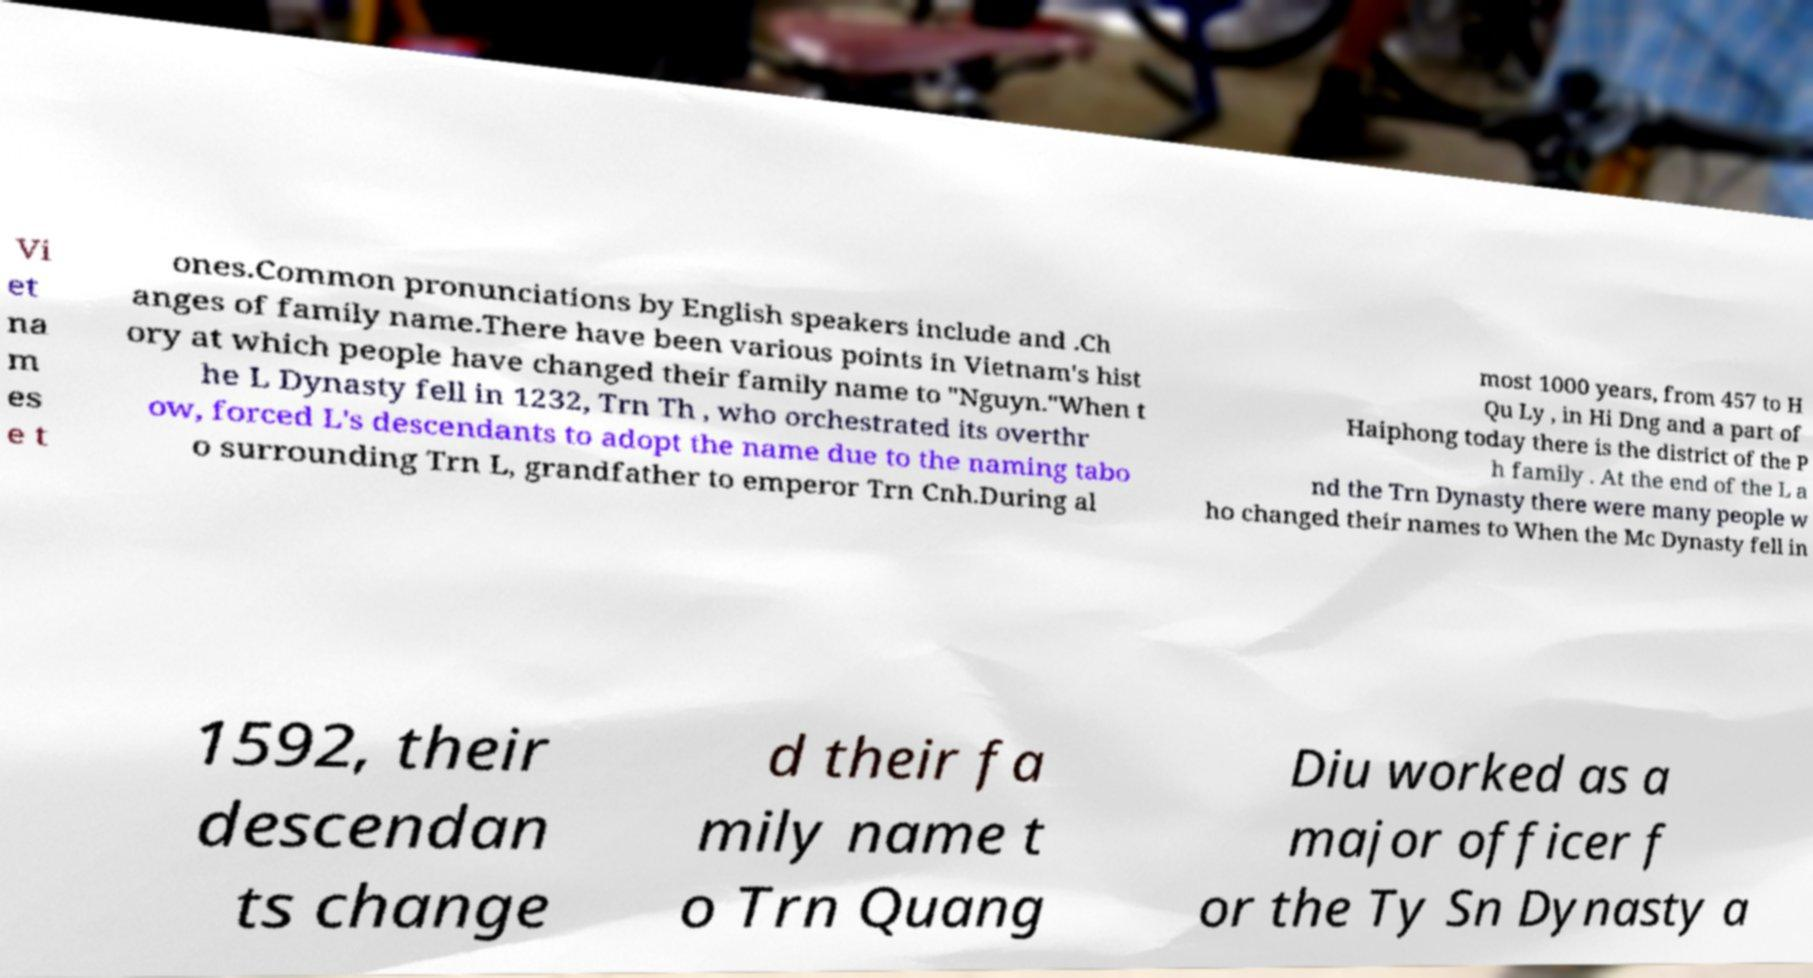What messages or text are displayed in this image? I need them in a readable, typed format. Vi et na m es e t ones.Common pronunciations by English speakers include and .Ch anges of family name.There have been various points in Vietnam's hist ory at which people have changed their family name to "Nguyn."When t he L Dynasty fell in 1232, Trn Th , who orchestrated its overthr ow, forced L's descendants to adopt the name due to the naming tabo o surrounding Trn L, grandfather to emperor Trn Cnh.During al most 1000 years, from 457 to H Qu Ly , in Hi Dng and a part of Haiphong today there is the district of the P h family . At the end of the L a nd the Trn Dynasty there were many people w ho changed their names to When the Mc Dynasty fell in 1592, their descendan ts change d their fa mily name t o Trn Quang Diu worked as a major officer f or the Ty Sn Dynasty a 